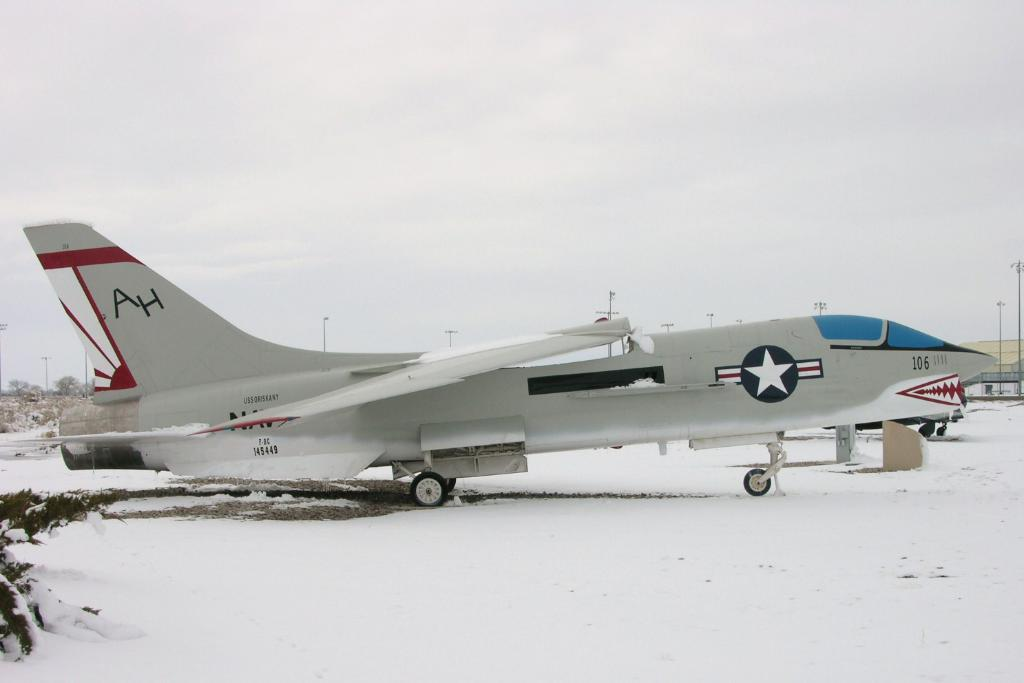<image>
Relay a brief, clear account of the picture shown. A grey fighter jet with AH written on the tail of it. 